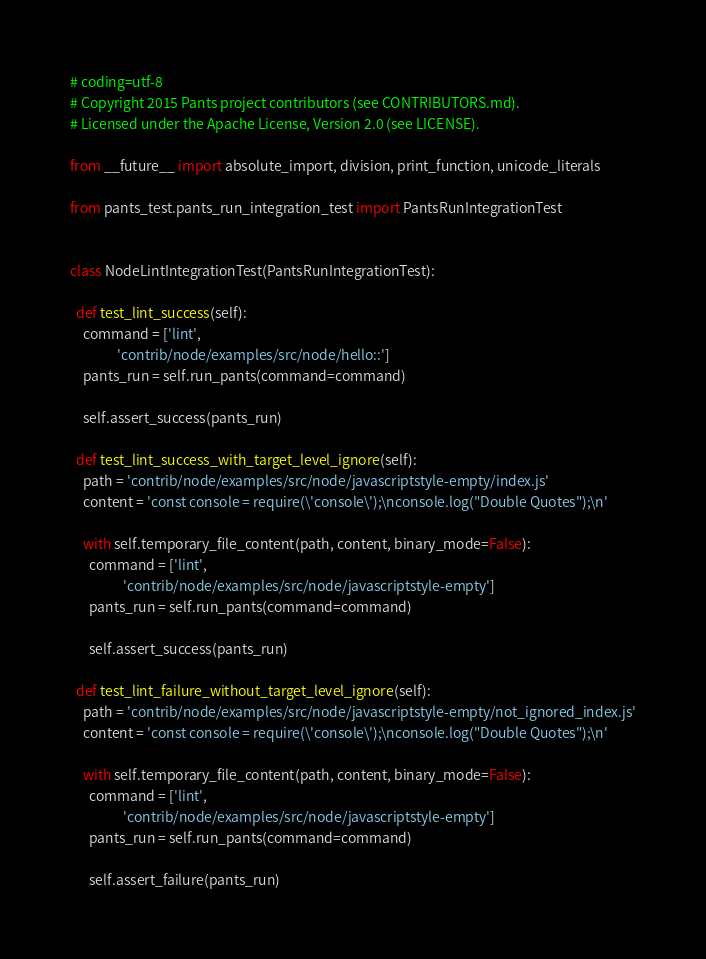<code> <loc_0><loc_0><loc_500><loc_500><_Python_># coding=utf-8
# Copyright 2015 Pants project contributors (see CONTRIBUTORS.md).
# Licensed under the Apache License, Version 2.0 (see LICENSE).

from __future__ import absolute_import, division, print_function, unicode_literals

from pants_test.pants_run_integration_test import PantsRunIntegrationTest


class NodeLintIntegrationTest(PantsRunIntegrationTest):

  def test_lint_success(self):
    command = ['lint',
               'contrib/node/examples/src/node/hello::']
    pants_run = self.run_pants(command=command)

    self.assert_success(pants_run)

  def test_lint_success_with_target_level_ignore(self):
    path = 'contrib/node/examples/src/node/javascriptstyle-empty/index.js'
    content = 'const console = require(\'console\');\nconsole.log("Double Quotes");\n'

    with self.temporary_file_content(path, content, binary_mode=False):
      command = ['lint',
                 'contrib/node/examples/src/node/javascriptstyle-empty']
      pants_run = self.run_pants(command=command)

      self.assert_success(pants_run)

  def test_lint_failure_without_target_level_ignore(self):
    path = 'contrib/node/examples/src/node/javascriptstyle-empty/not_ignored_index.js'
    content = 'const console = require(\'console\');\nconsole.log("Double Quotes");\n'

    with self.temporary_file_content(path, content, binary_mode=False):
      command = ['lint',
                 'contrib/node/examples/src/node/javascriptstyle-empty']
      pants_run = self.run_pants(command=command)

      self.assert_failure(pants_run)
</code> 